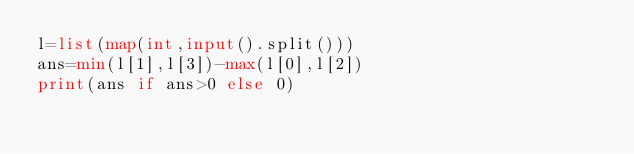Convert code to text. <code><loc_0><loc_0><loc_500><loc_500><_Python_>l=list(map(int,input().split()))
ans=min(l[1],l[3])-max(l[0],l[2])
print(ans if ans>0 else 0)</code> 